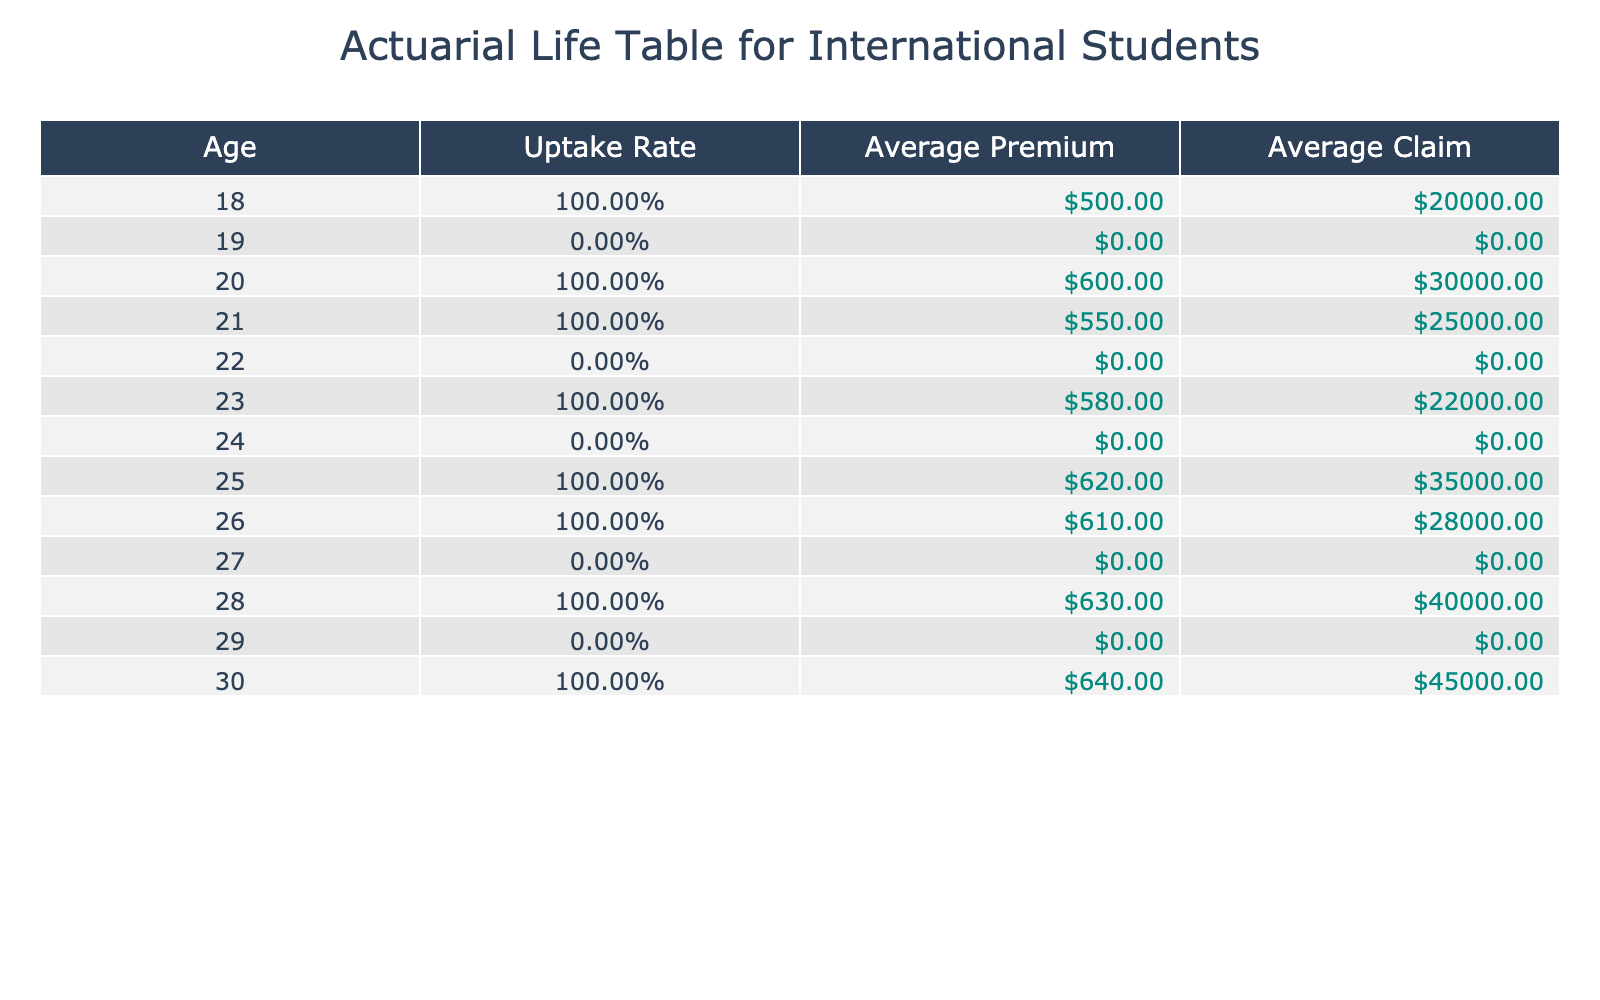What is the average uptake rate of life insurance among international students aged 18 to 30? To find the average uptake rate, we first identify the uptake rates for each age group from 18 to 30. The uptake rates are: 1 (Age 18), 0 (Age 19), 1 (Age 20), 1 (Age 21), 0 (Age 22), 1 (Age 23), 0 (Age 24), 1 (Age 25), 1 (Age 26), 0 (Age 27), 1 (Age 28), 0 (Age 29), 1 (Age 30). There are 13 entries total and the sum of the uptake rates is 7. Thus, the average uptake rate is 7/13 = 0.5385 or approximately 53.85%.
Answer: 53.85% What is the average premium paid by international students who have opted for life insurance? We focus only on the premium values where the uptake is "Yes". The premiums for those who opted are 500, 600, 550, 580, 620, 610, 630, 640. There are 8 premium values and the sum is 500 + 600 + 550 + 580 + 620 + 610 + 630 + 640 = 4340. The average is then 4340/8 = 542.5.
Answer: 542.5 How many international students aged 24 and younger have opted for life insurance? We look at the ages 18-24 and count the entries where the uptake is "Yes". The eligible ages are 18 (Yes), 19 (No), 20 (Yes), 21 (Yes), 22 (No), 23 (Yes), 24 (No). The total with "Yes" is 3 (from ages 18, 20, and 21). Hence, there are 3 students aged 24 and younger who signed up for life insurance.
Answer: 3 Is it true that the majority of female international students have opted for life insurance? To verify, we examine only female students: Ages 19 (No), 21 (Yes), 23 (Yes), 25 (Yes), 27 (No). The counts are 3 (opting Yes) and 2 (opting No). Since 3 is greater than 2, we conclude the majority of female international students have taken life insurance.
Answer: Yes What is the difference between the average claim amount for students who didn't opt for life insurance and those who did? We first find the average claim amounts. For those who took life insurance: 20000, 30000, 25000, 22000, 35000, 28000, 40000, 45000. The average claim is 20000 + 30000 + 25000 + 22000 + 35000 + 28000 + 40000 + 45000 = 225000 and dividing by 8 gives 28125. For those who didn't take it, the claims are all 0, thus the average claim value is 0. The difference is 28125 - 0 = 28125.
Answer: 28125 How many premium payments are greater than $600 among the insured group? We examine the premiums where the uptake is "Yes". The applicable premiums are 500, 600, 550, 580, 620, 610, 630, and 640. Among these, the amounts greater than 600 are 620, 610, 630, and 640. That gives us 4 premium payments exceeding 600.
Answer: 4 